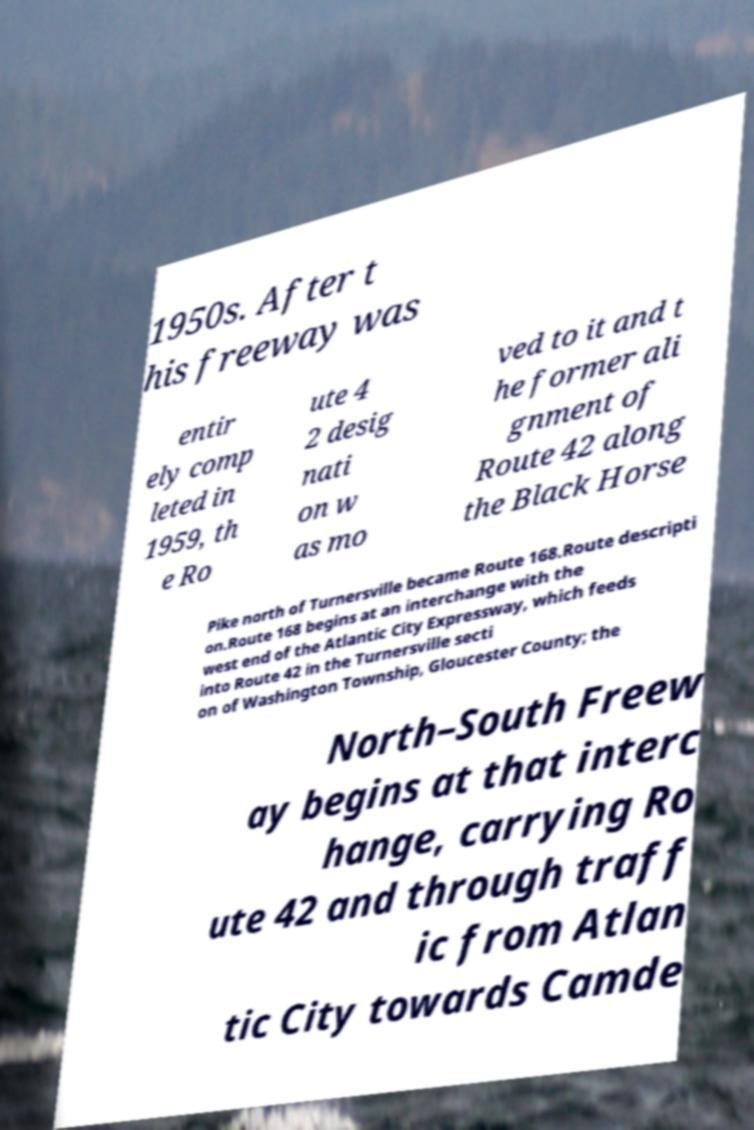Could you assist in decoding the text presented in this image and type it out clearly? 1950s. After t his freeway was entir ely comp leted in 1959, th e Ro ute 4 2 desig nati on w as mo ved to it and t he former ali gnment of Route 42 along the Black Horse Pike north of Turnersville became Route 168.Route descripti on.Route 168 begins at an interchange with the west end of the Atlantic City Expressway, which feeds into Route 42 in the Turnersville secti on of Washington Township, Gloucester County; the North–South Freew ay begins at that interc hange, carrying Ro ute 42 and through traff ic from Atlan tic City towards Camde 